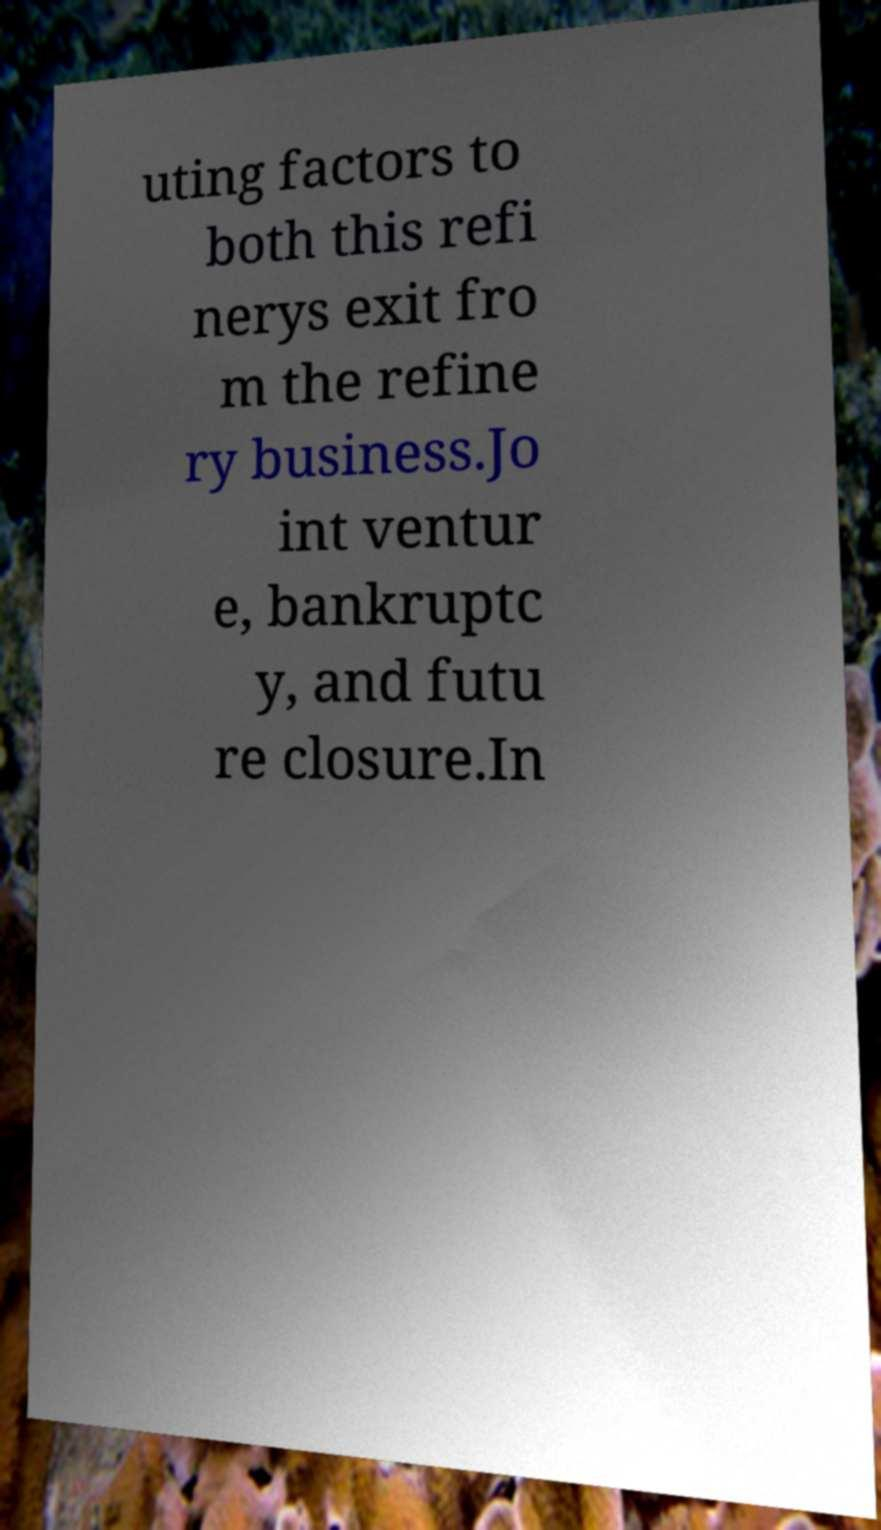Could you assist in decoding the text presented in this image and type it out clearly? uting factors to both this refi nerys exit fro m the refine ry business.Jo int ventur e, bankruptc y, and futu re closure.In 